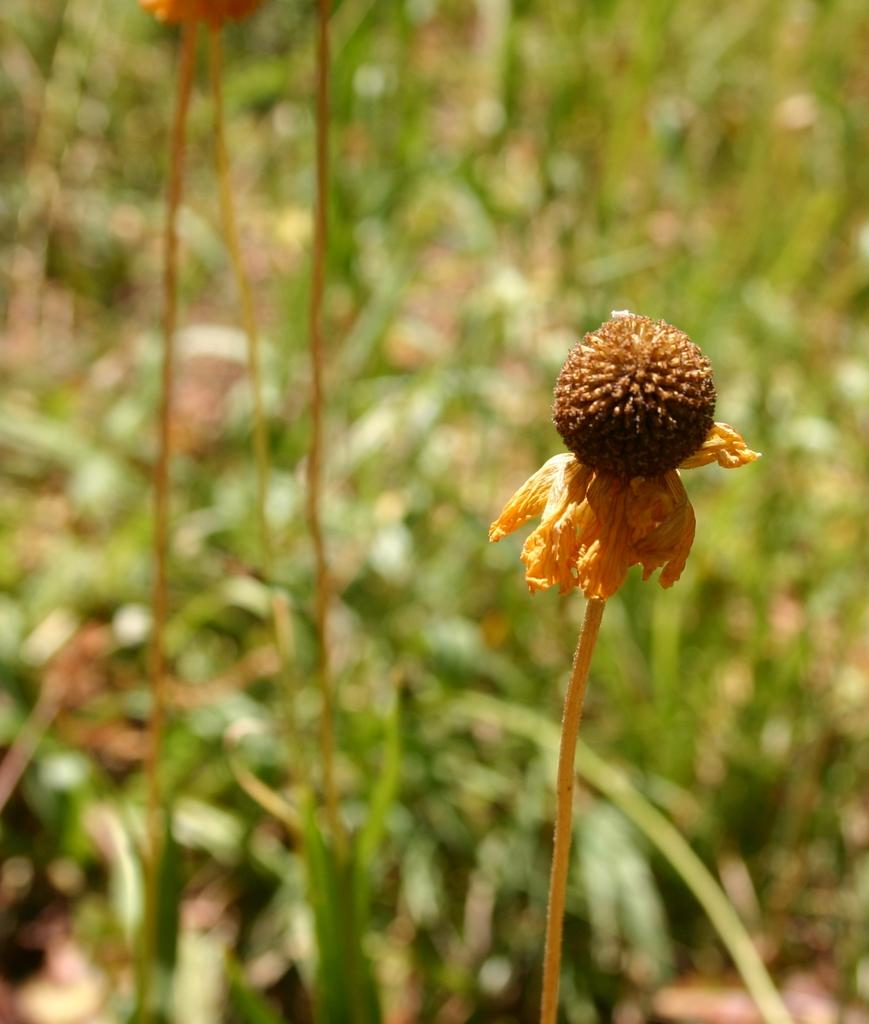What is the main subject of the image? The main subject of the image is a dried flower. How is the dried flower connected to the plant? The dried flower is attached to a plant. What can be observed about the background of the image? The background of the plant is blurred. Can you see any geese swimming in the lake in the background of the image? There is no lake or geese present in the image; it features a dried flower attached to a plant with a blurred background. 